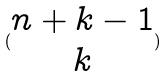Convert formula to latex. <formula><loc_0><loc_0><loc_500><loc_500>( \begin{matrix} n + k - 1 \\ k \end{matrix} )</formula> 